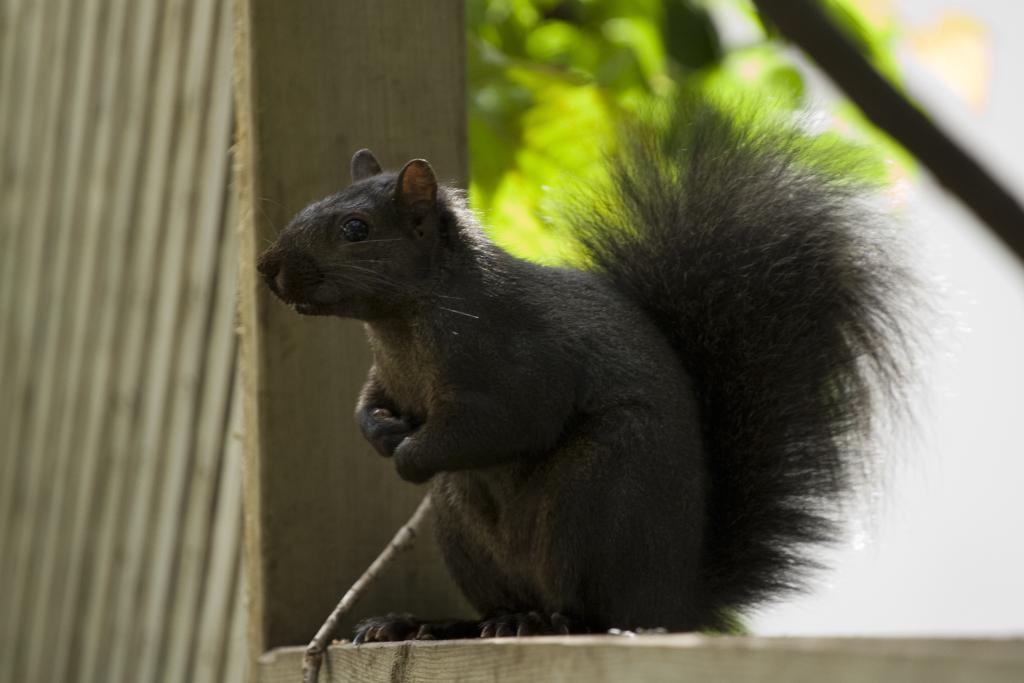How would you summarize this image in a sentence or two? In this picture I can see there is a squirrel which is sitting here on the wooden frame and in the background there are plants. 